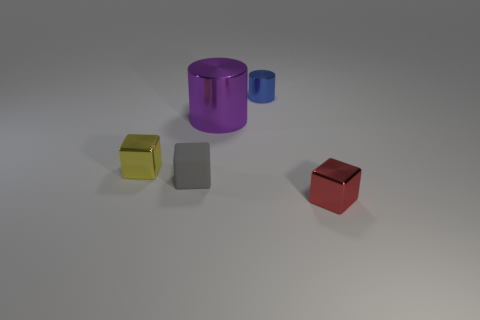There is a tiny thing that is on the right side of the purple object and behind the small red metal thing; what material is it made of?
Your answer should be compact. Metal. Do the yellow thing and the blue thing have the same material?
Your response must be concise. Yes. What size is the object that is both in front of the yellow metal block and on the left side of the tiny metallic cylinder?
Give a very brief answer. Small. There is a big purple thing; what shape is it?
Your answer should be very brief. Cylinder. How many objects are big cyan matte objects or small cubes that are to the right of the blue thing?
Give a very brief answer. 1. There is a cube to the left of the small gray thing; is its color the same as the small rubber cube?
Offer a very short reply. No. What is the color of the tiny object that is both behind the small rubber block and to the right of the small yellow metal object?
Your answer should be compact. Blue. What is the block that is right of the tiny gray block made of?
Make the answer very short. Metal. What is the size of the purple metal cylinder?
Give a very brief answer. Large. How many blue things are blocks or big metallic cylinders?
Keep it short and to the point. 0. 